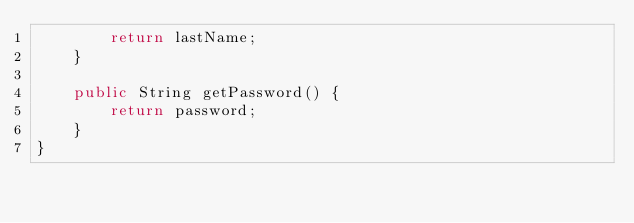Convert code to text. <code><loc_0><loc_0><loc_500><loc_500><_Java_>        return lastName;
    }

    public String getPassword() {
        return password;
    }
}
</code> 